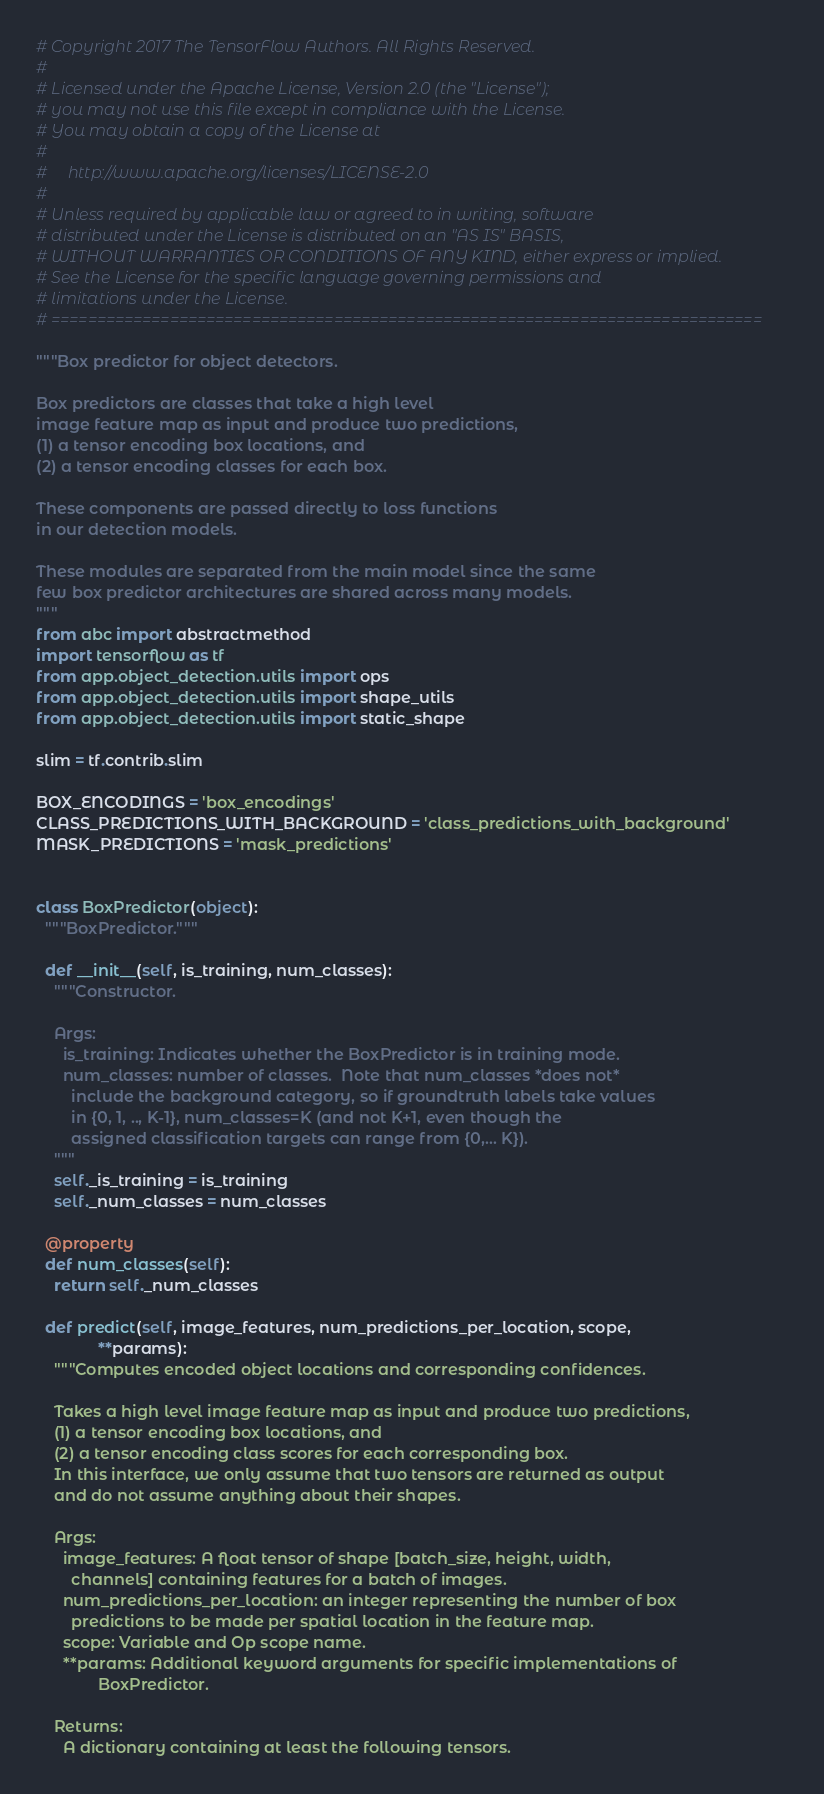<code> <loc_0><loc_0><loc_500><loc_500><_Python_># Copyright 2017 The TensorFlow Authors. All Rights Reserved.
#
# Licensed under the Apache License, Version 2.0 (the "License");
# you may not use this file except in compliance with the License.
# You may obtain a copy of the License at
#
#     http://www.apache.org/licenses/LICENSE-2.0
#
# Unless required by applicable law or agreed to in writing, software
# distributed under the License is distributed on an "AS IS" BASIS,
# WITHOUT WARRANTIES OR CONDITIONS OF ANY KIND, either express or implied.
# See the License for the specific language governing permissions and
# limitations under the License.
# ==============================================================================

"""Box predictor for object detectors.

Box predictors are classes that take a high level
image feature map as input and produce two predictions,
(1) a tensor encoding box locations, and
(2) a tensor encoding classes for each box.

These components are passed directly to loss functions
in our detection models.

These modules are separated from the main model since the same
few box predictor architectures are shared across many models.
"""
from abc import abstractmethod
import tensorflow as tf
from app.object_detection.utils import ops
from app.object_detection.utils import shape_utils
from app.object_detection.utils import static_shape

slim = tf.contrib.slim

BOX_ENCODINGS = 'box_encodings'
CLASS_PREDICTIONS_WITH_BACKGROUND = 'class_predictions_with_background'
MASK_PREDICTIONS = 'mask_predictions'


class BoxPredictor(object):
  """BoxPredictor."""

  def __init__(self, is_training, num_classes):
    """Constructor.

    Args:
      is_training: Indicates whether the BoxPredictor is in training mode.
      num_classes: number of classes.  Note that num_classes *does not*
        include the background category, so if groundtruth labels take values
        in {0, 1, .., K-1}, num_classes=K (and not K+1, even though the
        assigned classification targets can range from {0,... K}).
    """
    self._is_training = is_training
    self._num_classes = num_classes

  @property
  def num_classes(self):
    return self._num_classes

  def predict(self, image_features, num_predictions_per_location, scope,
              **params):
    """Computes encoded object locations and corresponding confidences.

    Takes a high level image feature map as input and produce two predictions,
    (1) a tensor encoding box locations, and
    (2) a tensor encoding class scores for each corresponding box.
    In this interface, we only assume that two tensors are returned as output
    and do not assume anything about their shapes.

    Args:
      image_features: A float tensor of shape [batch_size, height, width,
        channels] containing features for a batch of images.
      num_predictions_per_location: an integer representing the number of box
        predictions to be made per spatial location in the feature map.
      scope: Variable and Op scope name.
      **params: Additional keyword arguments for specific implementations of
              BoxPredictor.

    Returns:
      A dictionary containing at least the following tensors.</code> 